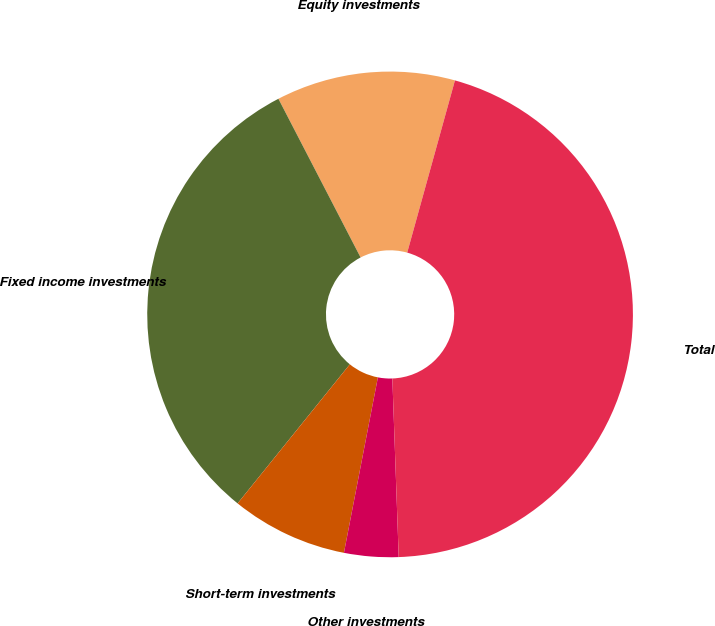Convert chart to OTSL. <chart><loc_0><loc_0><loc_500><loc_500><pie_chart><fcel>Equity investments<fcel>Fixed income investments<fcel>Short-term investments<fcel>Other investments<fcel>Total<nl><fcel>11.91%<fcel>31.59%<fcel>7.76%<fcel>3.61%<fcel>45.13%<nl></chart> 